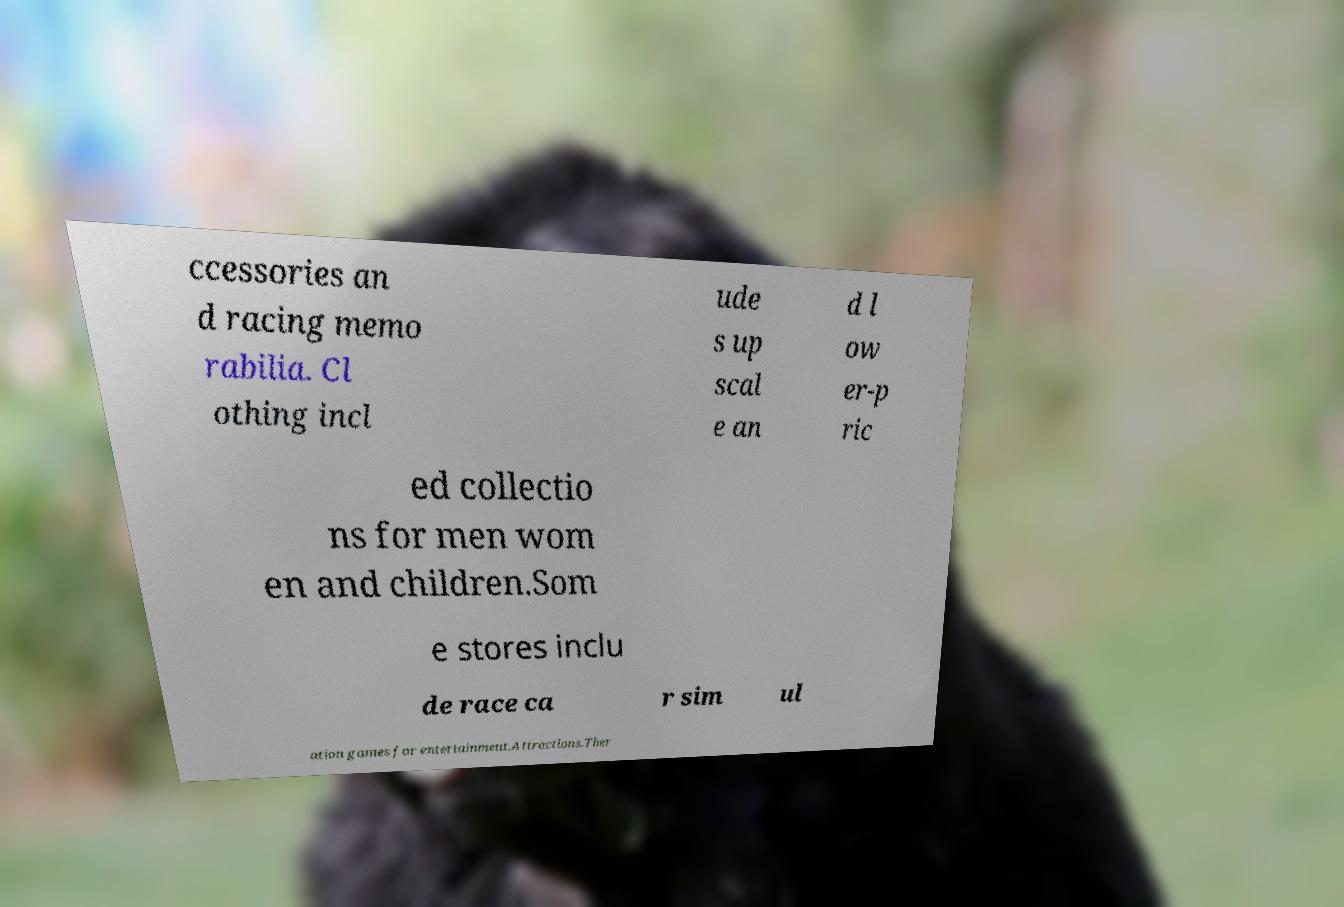Please read and relay the text visible in this image. What does it say? ccessories an d racing memo rabilia. Cl othing incl ude s up scal e an d l ow er-p ric ed collectio ns for men wom en and children.Som e stores inclu de race ca r sim ul ation games for entertainment.Attractions.Ther 